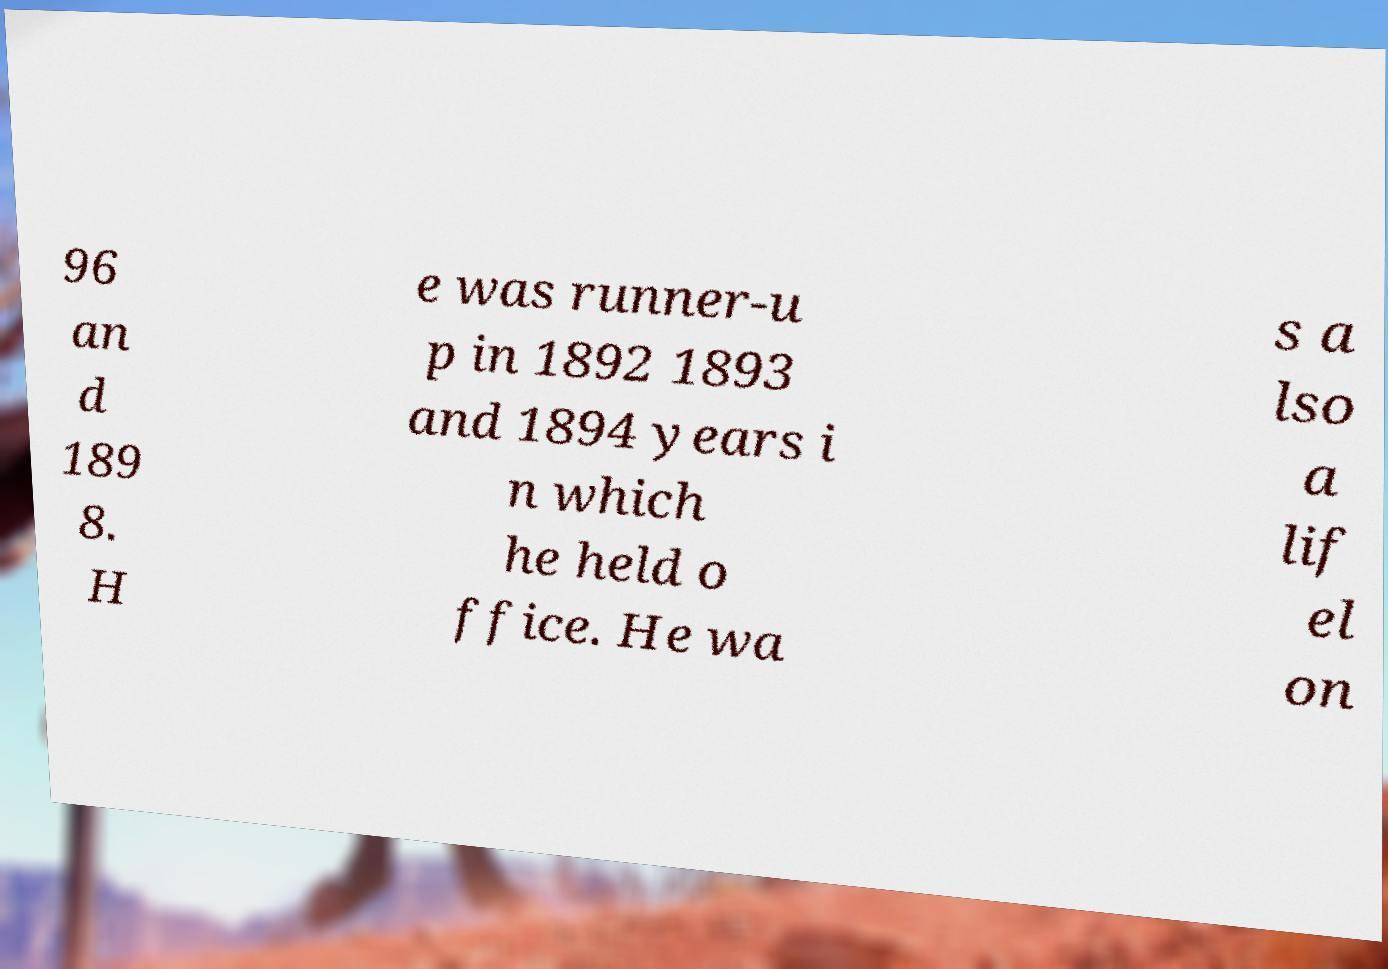Can you read and provide the text displayed in the image?This photo seems to have some interesting text. Can you extract and type it out for me? 96 an d 189 8. H e was runner-u p in 1892 1893 and 1894 years i n which he held o ffice. He wa s a lso a lif el on 